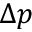Convert formula to latex. <formula><loc_0><loc_0><loc_500><loc_500>\Delta p</formula> 